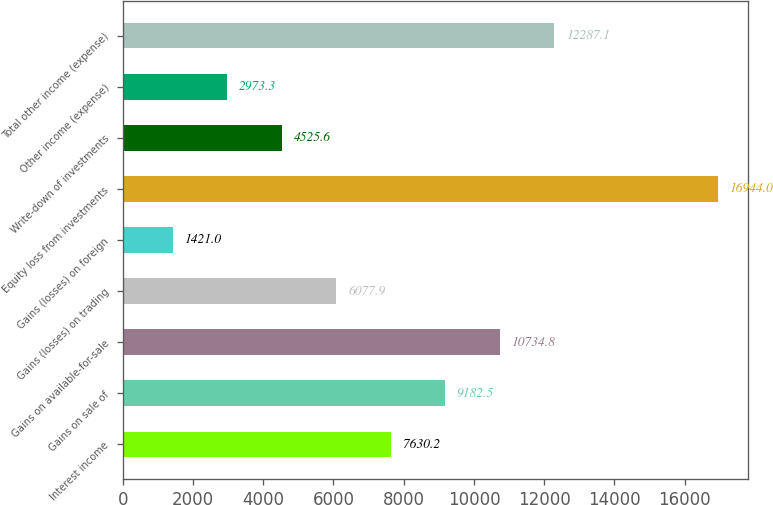Convert chart to OTSL. <chart><loc_0><loc_0><loc_500><loc_500><bar_chart><fcel>Interest income<fcel>Gains on sale of<fcel>Gains on available-for-sale<fcel>Gains (losses) on trading<fcel>Gains (losses) on foreign<fcel>Equity loss from investments<fcel>Write-down of investments<fcel>Other income (expense)<fcel>Total other income (expense)<nl><fcel>7630.2<fcel>9182.5<fcel>10734.8<fcel>6077.9<fcel>1421<fcel>16944<fcel>4525.6<fcel>2973.3<fcel>12287.1<nl></chart> 